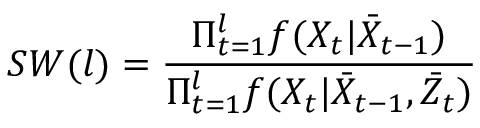<formula> <loc_0><loc_0><loc_500><loc_500>S W ( l ) = \frac { \Pi _ { t = 1 } ^ { l } f ( X _ { t } | \bar { X } _ { t - 1 } ) } { \Pi _ { t = 1 } ^ { l } f ( X _ { t } | \bar { X } _ { t - 1 } , \bar { Z } _ { t } ) }</formula> 